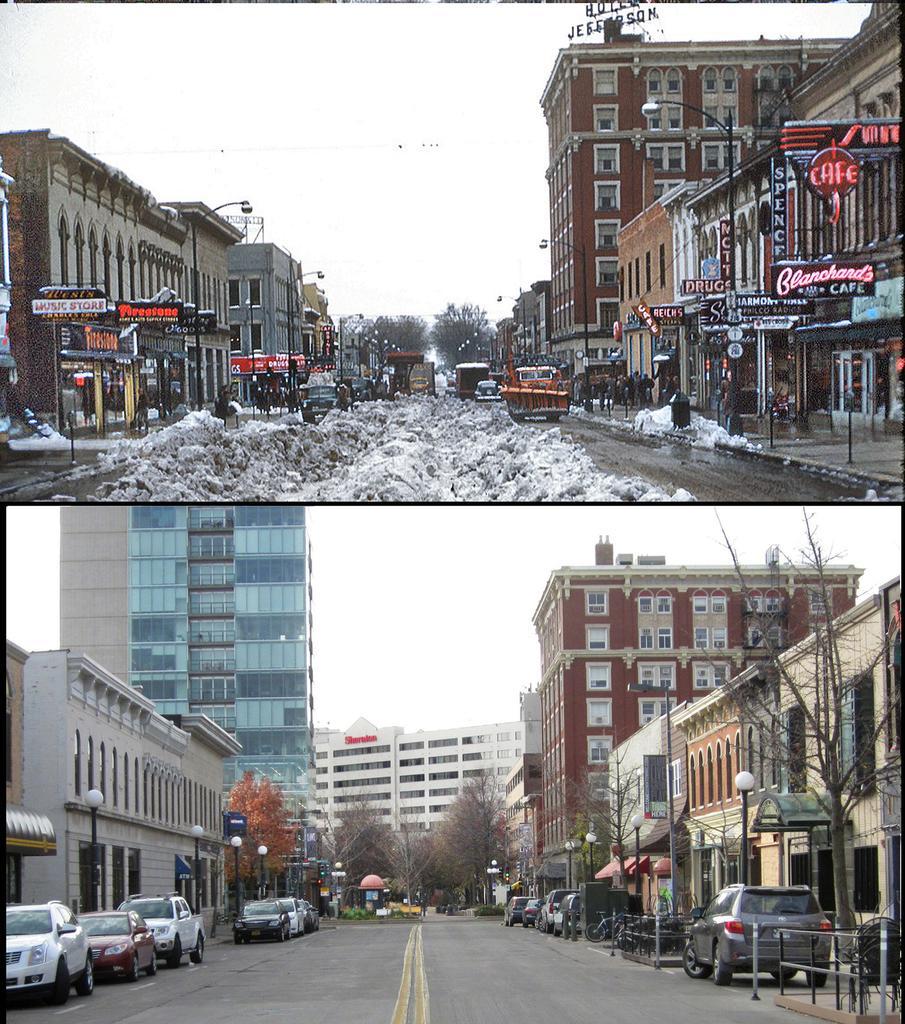Please provide a concise description of this image. In this image we can see many buildings. There is a collage photo. There are many trees in the image. There are many advertising boards at the top of the image. There are many street lights at the bottom of the image. There are many vehicles in the image. We can see the sky in the image. 